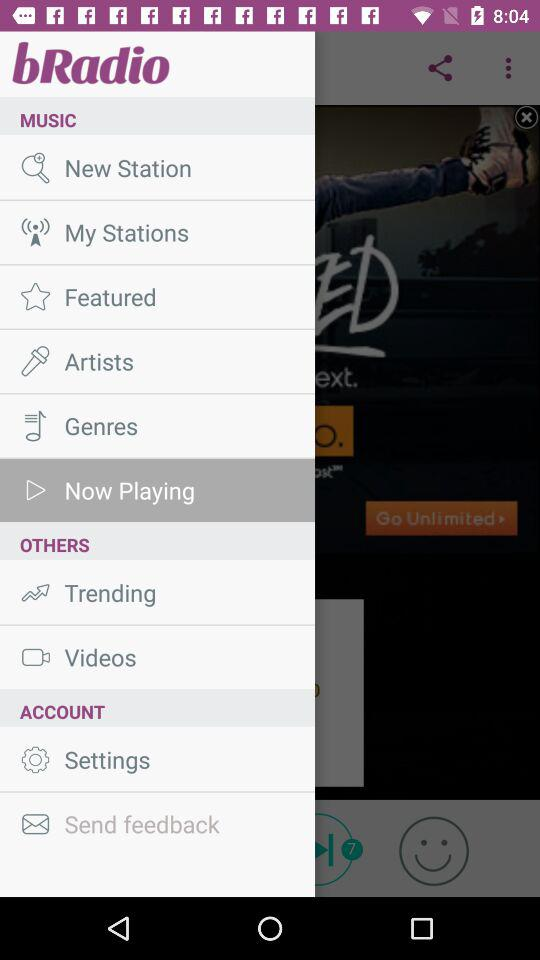What is the name of the application? The name of the application is "bRadio". 